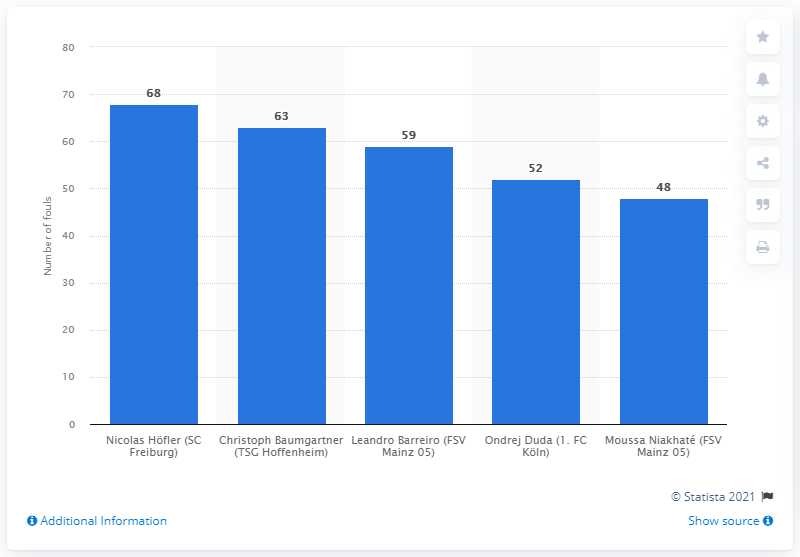Draw attention to some important aspects in this diagram. Nicolas Hfler committed a total of 68 fouls. 